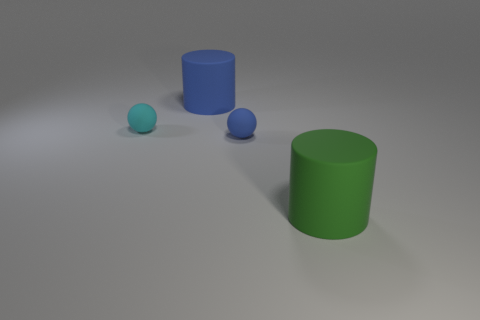Add 4 small purple metallic objects. How many objects exist? 8 Add 1 big blue matte things. How many big blue matte things are left? 2 Add 2 green cylinders. How many green cylinders exist? 3 Subtract 0 cyan cubes. How many objects are left? 4 Subtract all big blue objects. Subtract all small blue rubber objects. How many objects are left? 2 